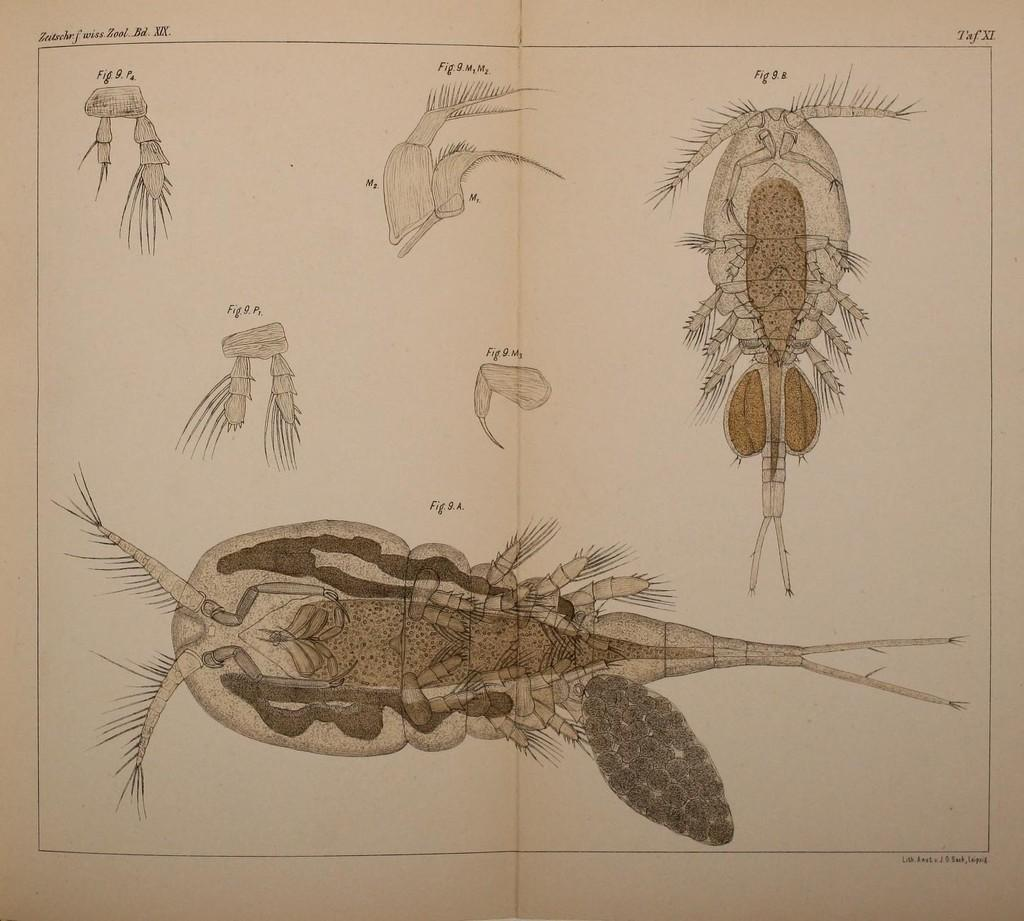What is the main subject of the image? The main subject of the image is a book. What is depicted on the book? There is a sketch of an internal structure and parts of insects on the book. Can you describe anything else visible in the image? There is text visible in the background of the image. What type of cherry is being used to clean the linen in the image? There is no cherry or linen present in the image; it features a book with a sketch of insects' internal structure and parts. 